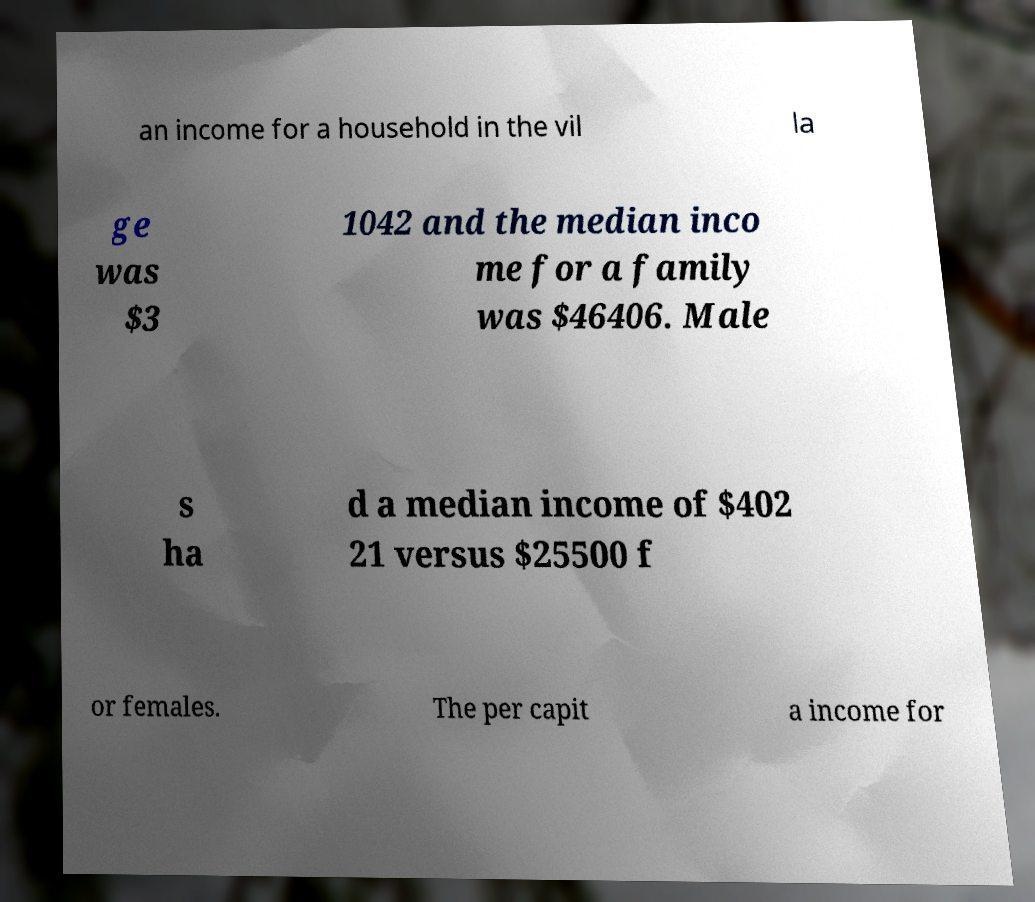For documentation purposes, I need the text within this image transcribed. Could you provide that? an income for a household in the vil la ge was $3 1042 and the median inco me for a family was $46406. Male s ha d a median income of $402 21 versus $25500 f or females. The per capit a income for 